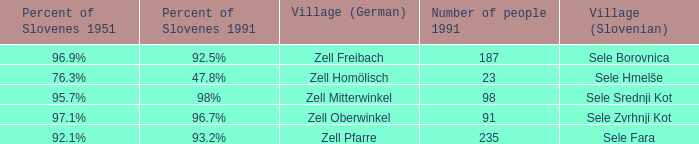Provide me with the name of the village (German) where there is 96.9% Slovenes in 1951.  Zell Freibach. 